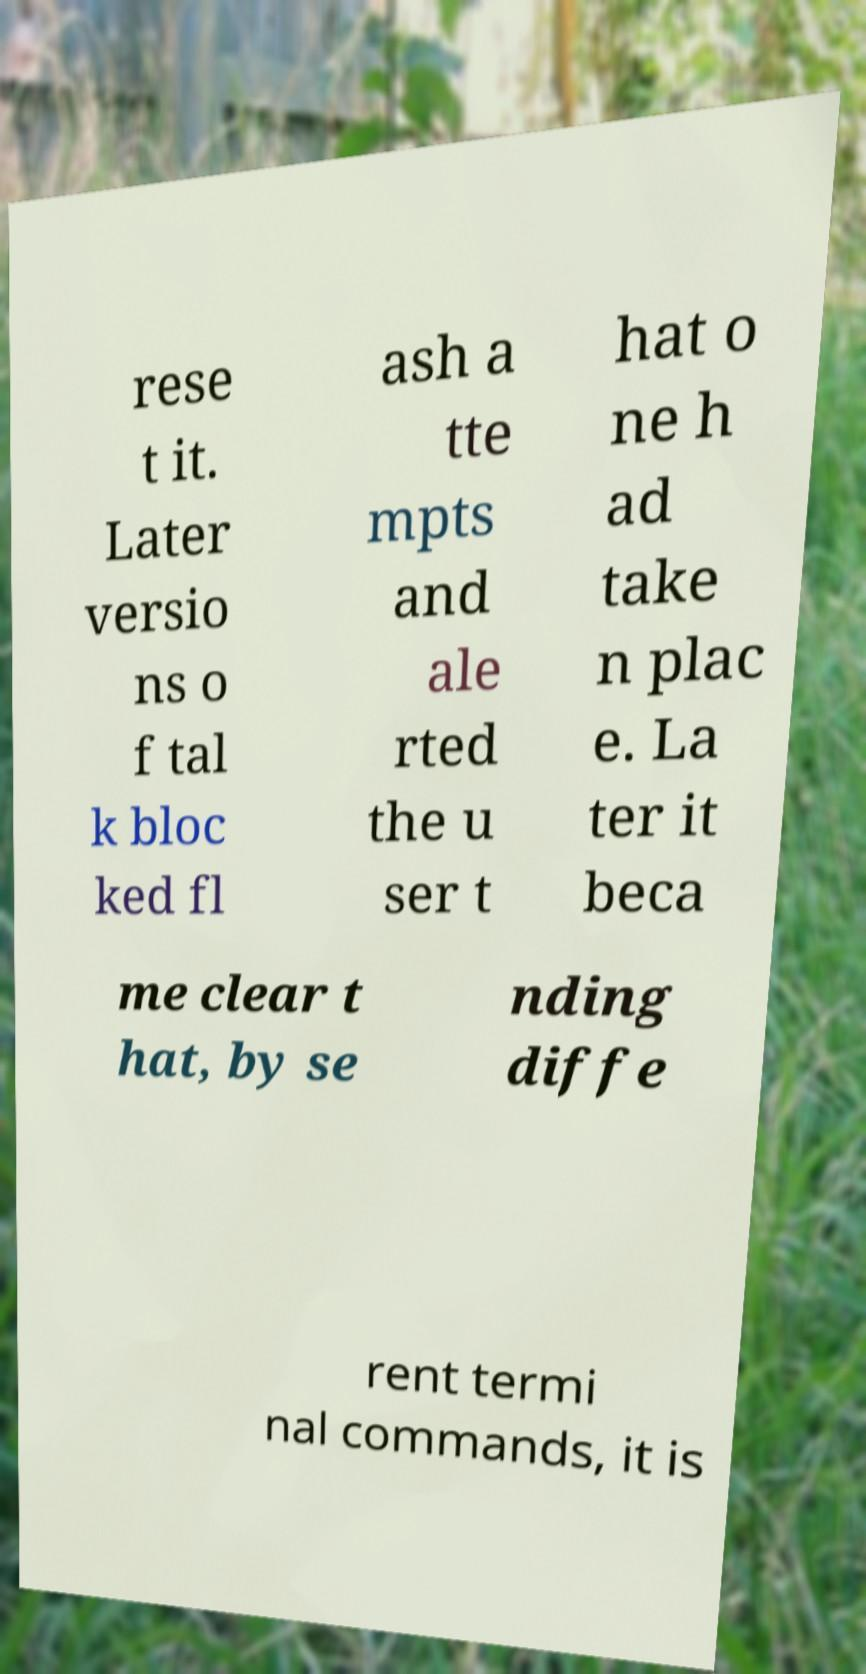Can you read and provide the text displayed in the image?This photo seems to have some interesting text. Can you extract and type it out for me? rese t it. Later versio ns o f tal k bloc ked fl ash a tte mpts and ale rted the u ser t hat o ne h ad take n plac e. La ter it beca me clear t hat, by se nding diffe rent termi nal commands, it is 